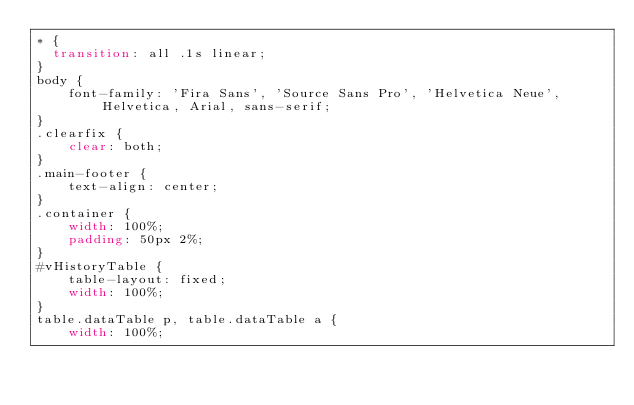Convert code to text. <code><loc_0><loc_0><loc_500><loc_500><_CSS_>* {
  transition: all .1s linear;  
}
body {
    font-family: 'Fira Sans', 'Source Sans Pro', 'Helvetica Neue', Helvetica, Arial, sans-serif;
}
.clearfix {
    clear: both;
}
.main-footer {
    text-align: center;
}
.container {
    width: 100%;
    padding: 50px 2%;
}
#vHistoryTable {
    table-layout: fixed;
    width: 100%;
}
table.dataTable p, table.dataTable a {
    width: 100%;</code> 